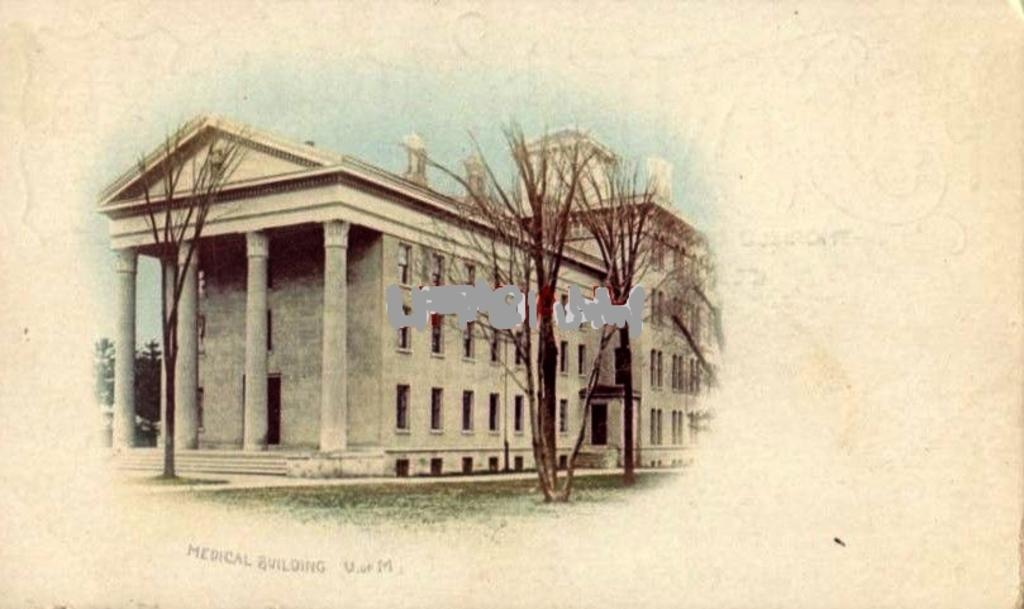What type of structure is present in the image? There is a building in the image. What can be seen in the foreground of the image? There are dried trees in the image. Is there any text present in the image? Yes, there is some text on the bottom of the image. What is visible in the background of the image? The sky is visible in the background of the image. What is the income of the bird flying in the image? There is no bird present in the image, so it is not possible to determine its income. 